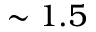<formula> <loc_0><loc_0><loc_500><loc_500>\sim 1 . 5</formula> 